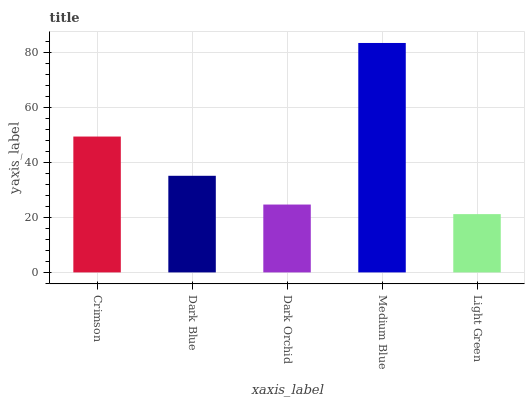Is Light Green the minimum?
Answer yes or no. Yes. Is Medium Blue the maximum?
Answer yes or no. Yes. Is Dark Blue the minimum?
Answer yes or no. No. Is Dark Blue the maximum?
Answer yes or no. No. Is Crimson greater than Dark Blue?
Answer yes or no. Yes. Is Dark Blue less than Crimson?
Answer yes or no. Yes. Is Dark Blue greater than Crimson?
Answer yes or no. No. Is Crimson less than Dark Blue?
Answer yes or no. No. Is Dark Blue the high median?
Answer yes or no. Yes. Is Dark Blue the low median?
Answer yes or no. Yes. Is Light Green the high median?
Answer yes or no. No. Is Light Green the low median?
Answer yes or no. No. 